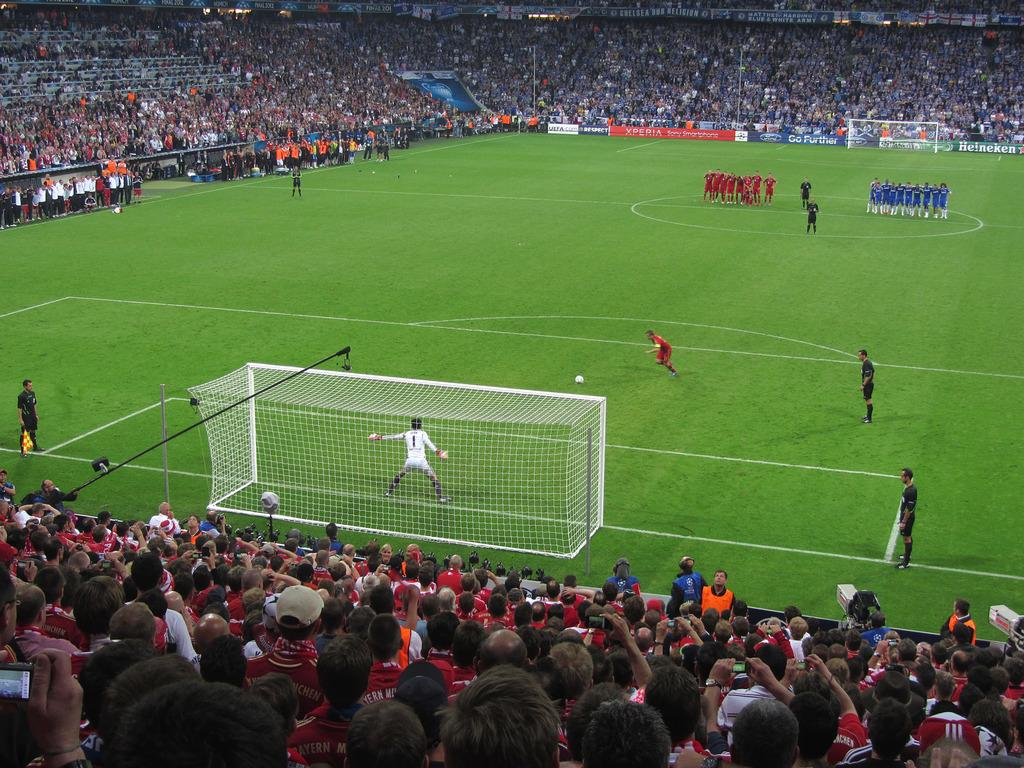Who or what can be seen in the image? There are people in the image. What object is present in the image that is commonly used in sports? There is a ball in the image. What structures are visible in the image that are used in the sport? There are goalposts in the image. What type of surface is visible in the image? The ground is visible in the image. What can be observed about the people's attire in the image? There are people with different color dresses around the ground. What other objects can be seen in the image besides the people and the ball? There are boards visible in the image. How does the beggar in the image twist the ball during the game? There is no beggar present in the image, and the ball is not being twisted during the game. 